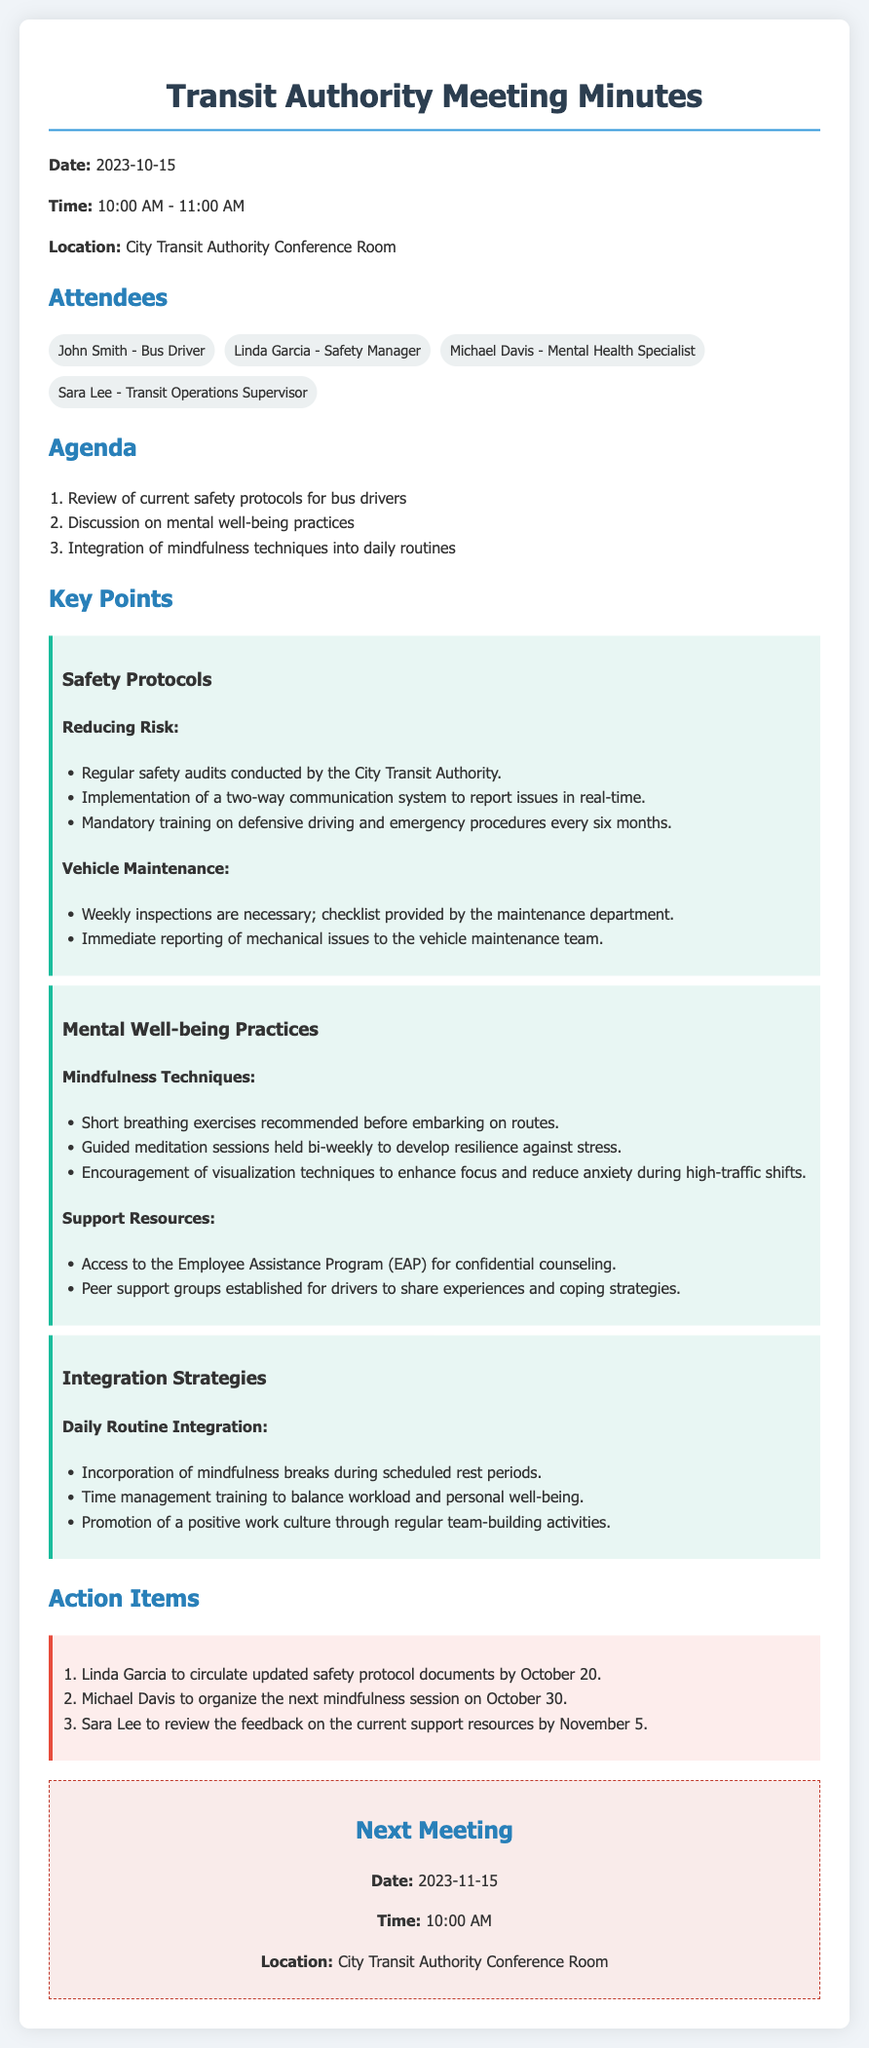What date was the meeting held? The meeting date is explicitly stated in the document as October 15, 2023.
Answer: October 15, 2023 Who is responsible for circulating updated safety protocol documents? The action item clearly states that Linda Garcia is tasked with this responsibility.
Answer: Linda Garcia How often are guided meditation sessions held? The document mentions that guided meditation sessions are held bi-weekly.
Answer: bi-weekly What is one recommended mindfulness technique before starting routes? The document lists short breathing exercises as a recommended technique before embarking on routes.
Answer: Short breathing exercises What is the next meeting's date? The next meeting's date is mentioned as November 15, 2023.
Answer: November 15, 2023 Who will organize the next mindfulness session? The document specifies that Michael Davis will organize the next mindfulness session.
Answer: Michael Davis What type of groups have been established for drivers? The document refers to peer support groups established for drivers.
Answer: Peer support groups What aspect of safety training is mandatory every six months? The document explains that defensive driving and emergency procedures training is mandatory every six months.
Answer: Defensive driving and emergency procedures What is one key strategy for daily routine integration mentioned? The document lists the incorporation of mindfulness breaks during scheduled rest periods as a key strategy.
Answer: Incorporation of mindfulness breaks 